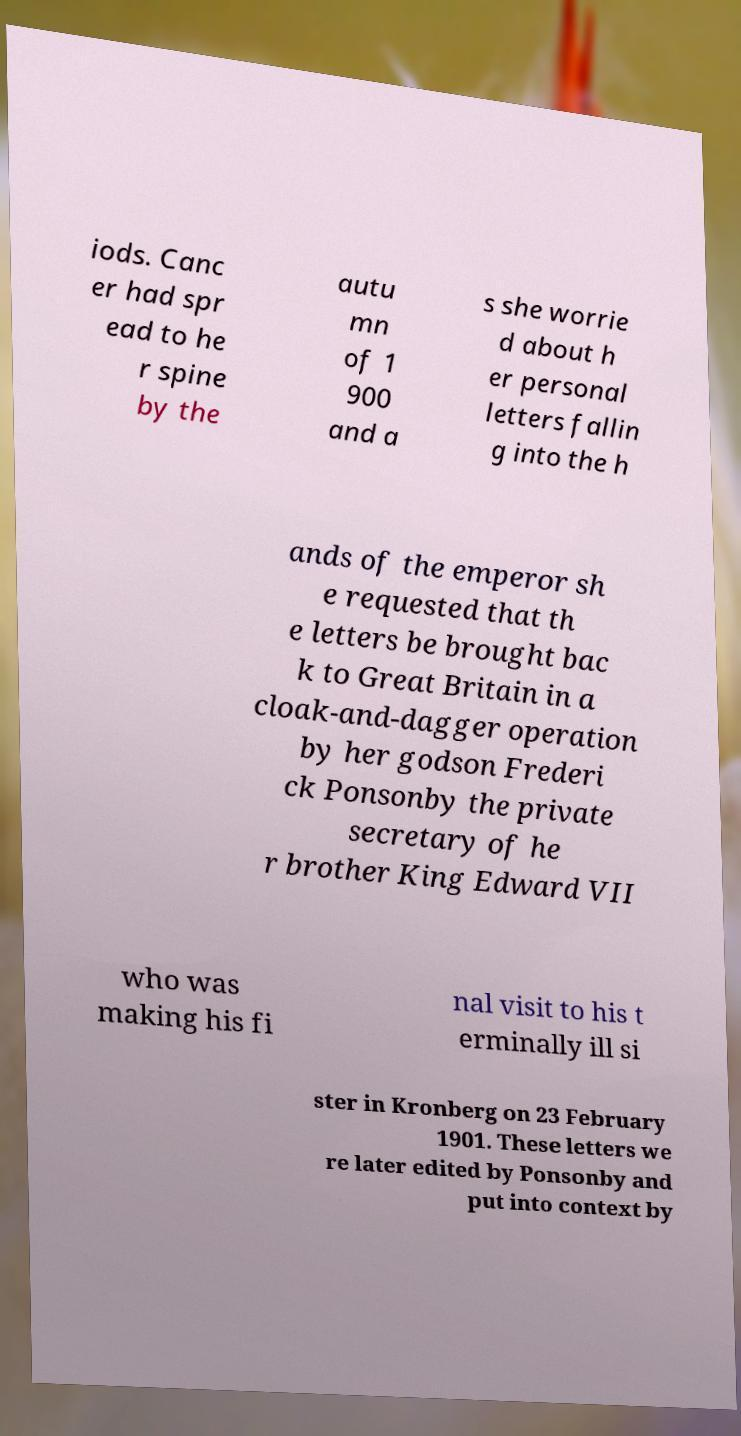Can you read and provide the text displayed in the image?This photo seems to have some interesting text. Can you extract and type it out for me? iods. Canc er had spr ead to he r spine by the autu mn of 1 900 and a s she worrie d about h er personal letters fallin g into the h ands of the emperor sh e requested that th e letters be brought bac k to Great Britain in a cloak-and-dagger operation by her godson Frederi ck Ponsonby the private secretary of he r brother King Edward VII who was making his fi nal visit to his t erminally ill si ster in Kronberg on 23 February 1901. These letters we re later edited by Ponsonby and put into context by 